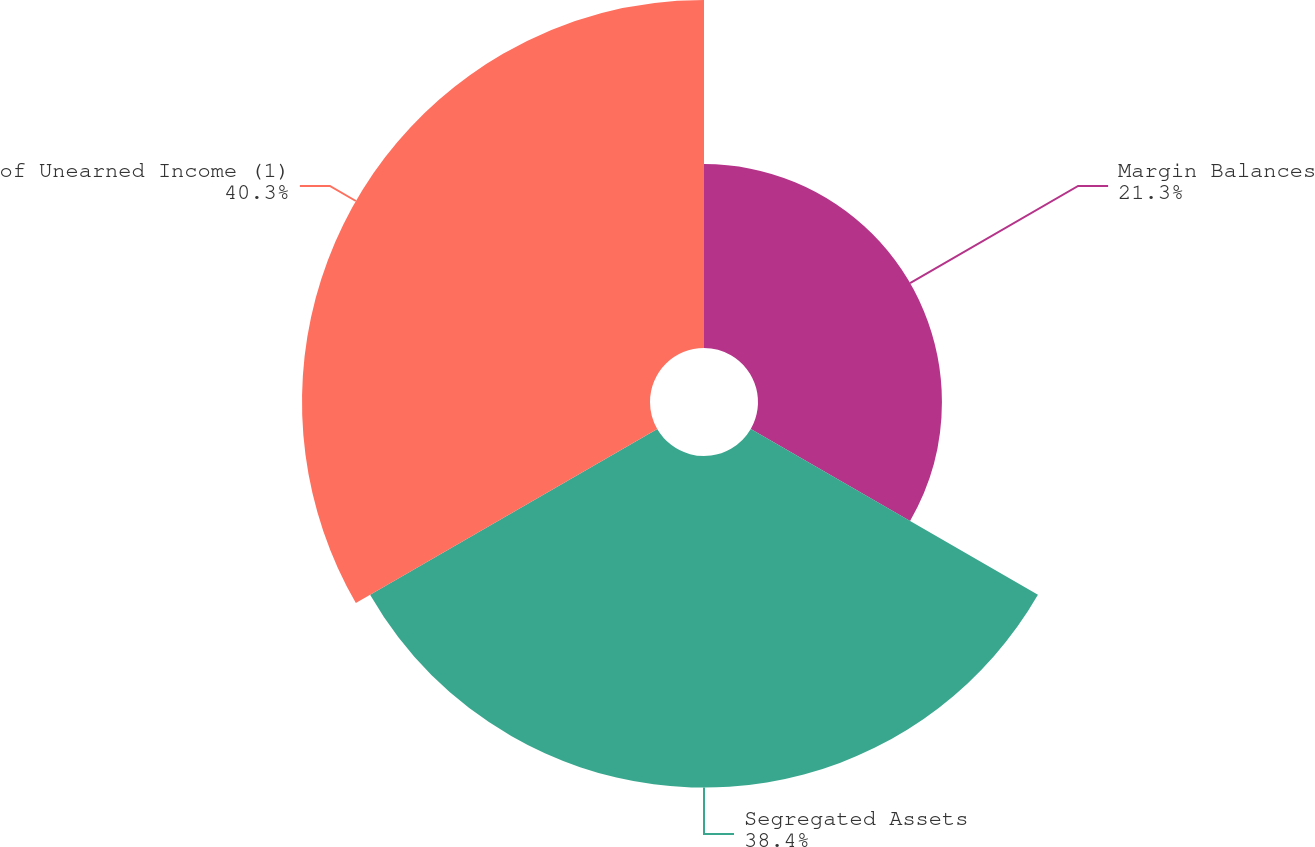Convert chart to OTSL. <chart><loc_0><loc_0><loc_500><loc_500><pie_chart><fcel>Margin Balances<fcel>Segregated Assets<fcel>of Unearned Income (1)<nl><fcel>21.3%<fcel>38.4%<fcel>40.3%<nl></chart> 